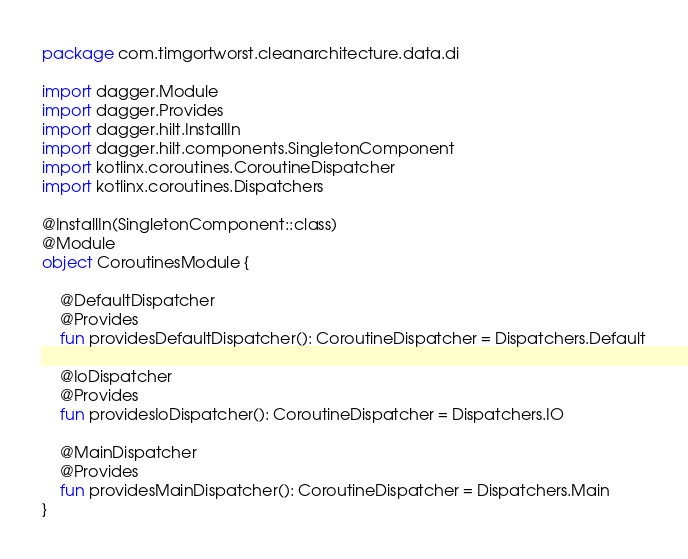Convert code to text. <code><loc_0><loc_0><loc_500><loc_500><_Kotlin_>package com.timgortworst.cleanarchitecture.data.di

import dagger.Module
import dagger.Provides
import dagger.hilt.InstallIn
import dagger.hilt.components.SingletonComponent
import kotlinx.coroutines.CoroutineDispatcher
import kotlinx.coroutines.Dispatchers

@InstallIn(SingletonComponent::class)
@Module
object CoroutinesModule {

    @DefaultDispatcher
    @Provides
    fun providesDefaultDispatcher(): CoroutineDispatcher = Dispatchers.Default

    @IoDispatcher
    @Provides
    fun providesIoDispatcher(): CoroutineDispatcher = Dispatchers.IO

    @MainDispatcher
    @Provides
    fun providesMainDispatcher(): CoroutineDispatcher = Dispatchers.Main
}
</code> 